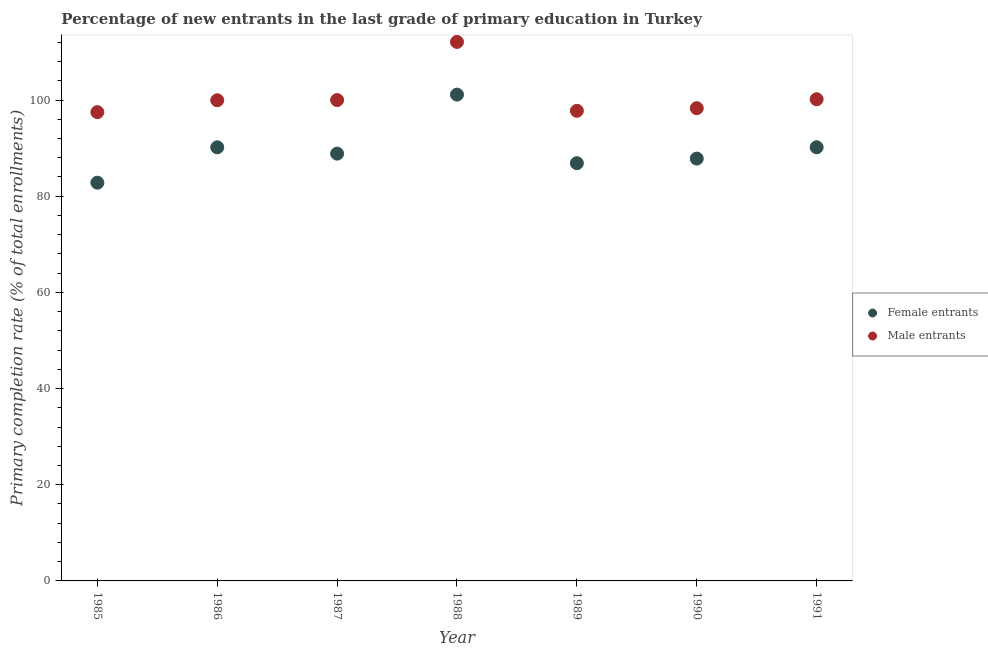How many different coloured dotlines are there?
Your response must be concise. 2. What is the primary completion rate of male entrants in 1987?
Keep it short and to the point. 99.99. Across all years, what is the maximum primary completion rate of male entrants?
Ensure brevity in your answer.  112.08. Across all years, what is the minimum primary completion rate of female entrants?
Your response must be concise. 82.81. In which year was the primary completion rate of male entrants maximum?
Provide a short and direct response. 1988. What is the total primary completion rate of female entrants in the graph?
Your answer should be very brief. 627.8. What is the difference between the primary completion rate of female entrants in 1988 and that in 1989?
Your answer should be very brief. 14.26. What is the difference between the primary completion rate of female entrants in 1985 and the primary completion rate of male entrants in 1990?
Give a very brief answer. -15.5. What is the average primary completion rate of female entrants per year?
Your answer should be very brief. 89.69. In the year 1985, what is the difference between the primary completion rate of male entrants and primary completion rate of female entrants?
Your response must be concise. 14.67. What is the ratio of the primary completion rate of male entrants in 1989 to that in 1990?
Give a very brief answer. 0.99. What is the difference between the highest and the second highest primary completion rate of male entrants?
Provide a succinct answer. 11.92. What is the difference between the highest and the lowest primary completion rate of male entrants?
Your answer should be very brief. 14.6. Is the sum of the primary completion rate of male entrants in 1985 and 1990 greater than the maximum primary completion rate of female entrants across all years?
Your response must be concise. Yes. Does the primary completion rate of female entrants monotonically increase over the years?
Offer a very short reply. No. Is the primary completion rate of male entrants strictly greater than the primary completion rate of female entrants over the years?
Your answer should be compact. Yes. Is the primary completion rate of male entrants strictly less than the primary completion rate of female entrants over the years?
Make the answer very short. No. How many dotlines are there?
Your response must be concise. 2. How many years are there in the graph?
Your answer should be very brief. 7. What is the difference between two consecutive major ticks on the Y-axis?
Your answer should be very brief. 20. Does the graph contain grids?
Provide a succinct answer. No. Where does the legend appear in the graph?
Your answer should be very brief. Center right. How many legend labels are there?
Make the answer very short. 2. How are the legend labels stacked?
Your answer should be compact. Vertical. What is the title of the graph?
Offer a very short reply. Percentage of new entrants in the last grade of primary education in Turkey. What is the label or title of the Y-axis?
Your response must be concise. Primary completion rate (% of total enrollments). What is the Primary completion rate (% of total enrollments) in Female entrants in 1985?
Your answer should be very brief. 82.81. What is the Primary completion rate (% of total enrollments) in Male entrants in 1985?
Provide a short and direct response. 97.48. What is the Primary completion rate (% of total enrollments) of Female entrants in 1986?
Provide a short and direct response. 90.16. What is the Primary completion rate (% of total enrollments) of Male entrants in 1986?
Your response must be concise. 99.95. What is the Primary completion rate (% of total enrollments) in Female entrants in 1987?
Offer a very short reply. 88.85. What is the Primary completion rate (% of total enrollments) in Male entrants in 1987?
Make the answer very short. 99.99. What is the Primary completion rate (% of total enrollments) of Female entrants in 1988?
Offer a very short reply. 101.12. What is the Primary completion rate (% of total enrollments) of Male entrants in 1988?
Your answer should be compact. 112.08. What is the Primary completion rate (% of total enrollments) in Female entrants in 1989?
Your answer should be compact. 86.86. What is the Primary completion rate (% of total enrollments) of Male entrants in 1989?
Give a very brief answer. 97.75. What is the Primary completion rate (% of total enrollments) in Female entrants in 1990?
Keep it short and to the point. 87.82. What is the Primary completion rate (% of total enrollments) of Male entrants in 1990?
Make the answer very short. 98.3. What is the Primary completion rate (% of total enrollments) in Female entrants in 1991?
Make the answer very short. 90.17. What is the Primary completion rate (% of total enrollments) in Male entrants in 1991?
Provide a short and direct response. 100.16. Across all years, what is the maximum Primary completion rate (% of total enrollments) in Female entrants?
Your response must be concise. 101.12. Across all years, what is the maximum Primary completion rate (% of total enrollments) of Male entrants?
Keep it short and to the point. 112.08. Across all years, what is the minimum Primary completion rate (% of total enrollments) in Female entrants?
Provide a succinct answer. 82.81. Across all years, what is the minimum Primary completion rate (% of total enrollments) in Male entrants?
Provide a succinct answer. 97.48. What is the total Primary completion rate (% of total enrollments) in Female entrants in the graph?
Keep it short and to the point. 627.8. What is the total Primary completion rate (% of total enrollments) of Male entrants in the graph?
Offer a very short reply. 705.71. What is the difference between the Primary completion rate (% of total enrollments) of Female entrants in 1985 and that in 1986?
Offer a very short reply. -7.35. What is the difference between the Primary completion rate (% of total enrollments) of Male entrants in 1985 and that in 1986?
Give a very brief answer. -2.47. What is the difference between the Primary completion rate (% of total enrollments) in Female entrants in 1985 and that in 1987?
Your answer should be compact. -6.05. What is the difference between the Primary completion rate (% of total enrollments) in Male entrants in 1985 and that in 1987?
Provide a short and direct response. -2.51. What is the difference between the Primary completion rate (% of total enrollments) of Female entrants in 1985 and that in 1988?
Provide a succinct answer. -18.32. What is the difference between the Primary completion rate (% of total enrollments) in Male entrants in 1985 and that in 1988?
Make the answer very short. -14.6. What is the difference between the Primary completion rate (% of total enrollments) of Female entrants in 1985 and that in 1989?
Keep it short and to the point. -4.06. What is the difference between the Primary completion rate (% of total enrollments) in Male entrants in 1985 and that in 1989?
Offer a terse response. -0.27. What is the difference between the Primary completion rate (% of total enrollments) of Female entrants in 1985 and that in 1990?
Your answer should be compact. -5.01. What is the difference between the Primary completion rate (% of total enrollments) in Male entrants in 1985 and that in 1990?
Make the answer very short. -0.82. What is the difference between the Primary completion rate (% of total enrollments) in Female entrants in 1985 and that in 1991?
Ensure brevity in your answer.  -7.37. What is the difference between the Primary completion rate (% of total enrollments) of Male entrants in 1985 and that in 1991?
Your response must be concise. -2.68. What is the difference between the Primary completion rate (% of total enrollments) of Female entrants in 1986 and that in 1987?
Give a very brief answer. 1.31. What is the difference between the Primary completion rate (% of total enrollments) in Male entrants in 1986 and that in 1987?
Provide a short and direct response. -0.04. What is the difference between the Primary completion rate (% of total enrollments) in Female entrants in 1986 and that in 1988?
Your response must be concise. -10.96. What is the difference between the Primary completion rate (% of total enrollments) in Male entrants in 1986 and that in 1988?
Your response must be concise. -12.14. What is the difference between the Primary completion rate (% of total enrollments) of Female entrants in 1986 and that in 1989?
Your answer should be very brief. 3.3. What is the difference between the Primary completion rate (% of total enrollments) in Male entrants in 1986 and that in 1989?
Provide a succinct answer. 2.19. What is the difference between the Primary completion rate (% of total enrollments) of Female entrants in 1986 and that in 1990?
Keep it short and to the point. 2.34. What is the difference between the Primary completion rate (% of total enrollments) of Male entrants in 1986 and that in 1990?
Give a very brief answer. 1.64. What is the difference between the Primary completion rate (% of total enrollments) in Female entrants in 1986 and that in 1991?
Give a very brief answer. -0.01. What is the difference between the Primary completion rate (% of total enrollments) of Male entrants in 1986 and that in 1991?
Offer a terse response. -0.21. What is the difference between the Primary completion rate (% of total enrollments) in Female entrants in 1987 and that in 1988?
Provide a short and direct response. -12.27. What is the difference between the Primary completion rate (% of total enrollments) of Male entrants in 1987 and that in 1988?
Offer a terse response. -12.1. What is the difference between the Primary completion rate (% of total enrollments) in Female entrants in 1987 and that in 1989?
Ensure brevity in your answer.  1.99. What is the difference between the Primary completion rate (% of total enrollments) in Male entrants in 1987 and that in 1989?
Your answer should be very brief. 2.23. What is the difference between the Primary completion rate (% of total enrollments) in Female entrants in 1987 and that in 1990?
Provide a succinct answer. 1.03. What is the difference between the Primary completion rate (% of total enrollments) of Male entrants in 1987 and that in 1990?
Make the answer very short. 1.68. What is the difference between the Primary completion rate (% of total enrollments) in Female entrants in 1987 and that in 1991?
Your answer should be very brief. -1.32. What is the difference between the Primary completion rate (% of total enrollments) of Male entrants in 1987 and that in 1991?
Your answer should be compact. -0.17. What is the difference between the Primary completion rate (% of total enrollments) of Female entrants in 1988 and that in 1989?
Provide a short and direct response. 14.26. What is the difference between the Primary completion rate (% of total enrollments) of Male entrants in 1988 and that in 1989?
Offer a terse response. 14.33. What is the difference between the Primary completion rate (% of total enrollments) of Female entrants in 1988 and that in 1990?
Make the answer very short. 13.3. What is the difference between the Primary completion rate (% of total enrollments) of Male entrants in 1988 and that in 1990?
Your answer should be compact. 13.78. What is the difference between the Primary completion rate (% of total enrollments) of Female entrants in 1988 and that in 1991?
Give a very brief answer. 10.95. What is the difference between the Primary completion rate (% of total enrollments) in Male entrants in 1988 and that in 1991?
Offer a terse response. 11.92. What is the difference between the Primary completion rate (% of total enrollments) of Female entrants in 1989 and that in 1990?
Keep it short and to the point. -0.96. What is the difference between the Primary completion rate (% of total enrollments) of Male entrants in 1989 and that in 1990?
Give a very brief answer. -0.55. What is the difference between the Primary completion rate (% of total enrollments) in Female entrants in 1989 and that in 1991?
Make the answer very short. -3.31. What is the difference between the Primary completion rate (% of total enrollments) in Male entrants in 1989 and that in 1991?
Your answer should be very brief. -2.41. What is the difference between the Primary completion rate (% of total enrollments) in Female entrants in 1990 and that in 1991?
Ensure brevity in your answer.  -2.35. What is the difference between the Primary completion rate (% of total enrollments) of Male entrants in 1990 and that in 1991?
Ensure brevity in your answer.  -1.86. What is the difference between the Primary completion rate (% of total enrollments) in Female entrants in 1985 and the Primary completion rate (% of total enrollments) in Male entrants in 1986?
Ensure brevity in your answer.  -17.14. What is the difference between the Primary completion rate (% of total enrollments) in Female entrants in 1985 and the Primary completion rate (% of total enrollments) in Male entrants in 1987?
Ensure brevity in your answer.  -17.18. What is the difference between the Primary completion rate (% of total enrollments) of Female entrants in 1985 and the Primary completion rate (% of total enrollments) of Male entrants in 1988?
Make the answer very short. -29.28. What is the difference between the Primary completion rate (% of total enrollments) in Female entrants in 1985 and the Primary completion rate (% of total enrollments) in Male entrants in 1989?
Make the answer very short. -14.95. What is the difference between the Primary completion rate (% of total enrollments) of Female entrants in 1985 and the Primary completion rate (% of total enrollments) of Male entrants in 1990?
Keep it short and to the point. -15.5. What is the difference between the Primary completion rate (% of total enrollments) in Female entrants in 1985 and the Primary completion rate (% of total enrollments) in Male entrants in 1991?
Your answer should be very brief. -17.35. What is the difference between the Primary completion rate (% of total enrollments) of Female entrants in 1986 and the Primary completion rate (% of total enrollments) of Male entrants in 1987?
Offer a terse response. -9.83. What is the difference between the Primary completion rate (% of total enrollments) in Female entrants in 1986 and the Primary completion rate (% of total enrollments) in Male entrants in 1988?
Ensure brevity in your answer.  -21.92. What is the difference between the Primary completion rate (% of total enrollments) in Female entrants in 1986 and the Primary completion rate (% of total enrollments) in Male entrants in 1989?
Provide a short and direct response. -7.59. What is the difference between the Primary completion rate (% of total enrollments) in Female entrants in 1986 and the Primary completion rate (% of total enrollments) in Male entrants in 1990?
Ensure brevity in your answer.  -8.14. What is the difference between the Primary completion rate (% of total enrollments) of Female entrants in 1986 and the Primary completion rate (% of total enrollments) of Male entrants in 1991?
Make the answer very short. -10. What is the difference between the Primary completion rate (% of total enrollments) in Female entrants in 1987 and the Primary completion rate (% of total enrollments) in Male entrants in 1988?
Keep it short and to the point. -23.23. What is the difference between the Primary completion rate (% of total enrollments) of Female entrants in 1987 and the Primary completion rate (% of total enrollments) of Male entrants in 1989?
Provide a succinct answer. -8.9. What is the difference between the Primary completion rate (% of total enrollments) in Female entrants in 1987 and the Primary completion rate (% of total enrollments) in Male entrants in 1990?
Provide a short and direct response. -9.45. What is the difference between the Primary completion rate (% of total enrollments) in Female entrants in 1987 and the Primary completion rate (% of total enrollments) in Male entrants in 1991?
Your answer should be very brief. -11.31. What is the difference between the Primary completion rate (% of total enrollments) in Female entrants in 1988 and the Primary completion rate (% of total enrollments) in Male entrants in 1989?
Give a very brief answer. 3.37. What is the difference between the Primary completion rate (% of total enrollments) of Female entrants in 1988 and the Primary completion rate (% of total enrollments) of Male entrants in 1990?
Make the answer very short. 2.82. What is the difference between the Primary completion rate (% of total enrollments) in Female entrants in 1988 and the Primary completion rate (% of total enrollments) in Male entrants in 1991?
Provide a succinct answer. 0.96. What is the difference between the Primary completion rate (% of total enrollments) in Female entrants in 1989 and the Primary completion rate (% of total enrollments) in Male entrants in 1990?
Your answer should be compact. -11.44. What is the difference between the Primary completion rate (% of total enrollments) in Female entrants in 1989 and the Primary completion rate (% of total enrollments) in Male entrants in 1991?
Provide a short and direct response. -13.3. What is the difference between the Primary completion rate (% of total enrollments) in Female entrants in 1990 and the Primary completion rate (% of total enrollments) in Male entrants in 1991?
Your response must be concise. -12.34. What is the average Primary completion rate (% of total enrollments) of Female entrants per year?
Provide a short and direct response. 89.69. What is the average Primary completion rate (% of total enrollments) of Male entrants per year?
Your answer should be very brief. 100.82. In the year 1985, what is the difference between the Primary completion rate (% of total enrollments) in Female entrants and Primary completion rate (% of total enrollments) in Male entrants?
Offer a terse response. -14.67. In the year 1986, what is the difference between the Primary completion rate (% of total enrollments) in Female entrants and Primary completion rate (% of total enrollments) in Male entrants?
Provide a succinct answer. -9.79. In the year 1987, what is the difference between the Primary completion rate (% of total enrollments) in Female entrants and Primary completion rate (% of total enrollments) in Male entrants?
Your answer should be very brief. -11.13. In the year 1988, what is the difference between the Primary completion rate (% of total enrollments) of Female entrants and Primary completion rate (% of total enrollments) of Male entrants?
Make the answer very short. -10.96. In the year 1989, what is the difference between the Primary completion rate (% of total enrollments) in Female entrants and Primary completion rate (% of total enrollments) in Male entrants?
Ensure brevity in your answer.  -10.89. In the year 1990, what is the difference between the Primary completion rate (% of total enrollments) in Female entrants and Primary completion rate (% of total enrollments) in Male entrants?
Your answer should be compact. -10.48. In the year 1991, what is the difference between the Primary completion rate (% of total enrollments) in Female entrants and Primary completion rate (% of total enrollments) in Male entrants?
Your response must be concise. -9.98. What is the ratio of the Primary completion rate (% of total enrollments) in Female entrants in 1985 to that in 1986?
Provide a succinct answer. 0.92. What is the ratio of the Primary completion rate (% of total enrollments) of Male entrants in 1985 to that in 1986?
Your answer should be compact. 0.98. What is the ratio of the Primary completion rate (% of total enrollments) of Female entrants in 1985 to that in 1987?
Provide a short and direct response. 0.93. What is the ratio of the Primary completion rate (% of total enrollments) of Male entrants in 1985 to that in 1987?
Ensure brevity in your answer.  0.97. What is the ratio of the Primary completion rate (% of total enrollments) of Female entrants in 1985 to that in 1988?
Make the answer very short. 0.82. What is the ratio of the Primary completion rate (% of total enrollments) of Male entrants in 1985 to that in 1988?
Make the answer very short. 0.87. What is the ratio of the Primary completion rate (% of total enrollments) of Female entrants in 1985 to that in 1989?
Your answer should be compact. 0.95. What is the ratio of the Primary completion rate (% of total enrollments) of Female entrants in 1985 to that in 1990?
Your answer should be compact. 0.94. What is the ratio of the Primary completion rate (% of total enrollments) of Female entrants in 1985 to that in 1991?
Offer a very short reply. 0.92. What is the ratio of the Primary completion rate (% of total enrollments) in Male entrants in 1985 to that in 1991?
Ensure brevity in your answer.  0.97. What is the ratio of the Primary completion rate (% of total enrollments) in Female entrants in 1986 to that in 1987?
Provide a short and direct response. 1.01. What is the ratio of the Primary completion rate (% of total enrollments) in Male entrants in 1986 to that in 1987?
Provide a succinct answer. 1. What is the ratio of the Primary completion rate (% of total enrollments) in Female entrants in 1986 to that in 1988?
Your answer should be very brief. 0.89. What is the ratio of the Primary completion rate (% of total enrollments) of Male entrants in 1986 to that in 1988?
Ensure brevity in your answer.  0.89. What is the ratio of the Primary completion rate (% of total enrollments) of Female entrants in 1986 to that in 1989?
Offer a terse response. 1.04. What is the ratio of the Primary completion rate (% of total enrollments) of Male entrants in 1986 to that in 1989?
Ensure brevity in your answer.  1.02. What is the ratio of the Primary completion rate (% of total enrollments) in Female entrants in 1986 to that in 1990?
Your answer should be compact. 1.03. What is the ratio of the Primary completion rate (% of total enrollments) in Male entrants in 1986 to that in 1990?
Your answer should be compact. 1.02. What is the ratio of the Primary completion rate (% of total enrollments) in Female entrants in 1987 to that in 1988?
Keep it short and to the point. 0.88. What is the ratio of the Primary completion rate (% of total enrollments) in Male entrants in 1987 to that in 1988?
Offer a terse response. 0.89. What is the ratio of the Primary completion rate (% of total enrollments) of Female entrants in 1987 to that in 1989?
Give a very brief answer. 1.02. What is the ratio of the Primary completion rate (% of total enrollments) in Male entrants in 1987 to that in 1989?
Offer a very short reply. 1.02. What is the ratio of the Primary completion rate (% of total enrollments) in Female entrants in 1987 to that in 1990?
Make the answer very short. 1.01. What is the ratio of the Primary completion rate (% of total enrollments) of Male entrants in 1987 to that in 1990?
Provide a short and direct response. 1.02. What is the ratio of the Primary completion rate (% of total enrollments) of Female entrants in 1987 to that in 1991?
Your answer should be very brief. 0.99. What is the ratio of the Primary completion rate (% of total enrollments) in Male entrants in 1987 to that in 1991?
Give a very brief answer. 1. What is the ratio of the Primary completion rate (% of total enrollments) of Female entrants in 1988 to that in 1989?
Your answer should be compact. 1.16. What is the ratio of the Primary completion rate (% of total enrollments) in Male entrants in 1988 to that in 1989?
Ensure brevity in your answer.  1.15. What is the ratio of the Primary completion rate (% of total enrollments) of Female entrants in 1988 to that in 1990?
Offer a very short reply. 1.15. What is the ratio of the Primary completion rate (% of total enrollments) in Male entrants in 1988 to that in 1990?
Your answer should be very brief. 1.14. What is the ratio of the Primary completion rate (% of total enrollments) in Female entrants in 1988 to that in 1991?
Give a very brief answer. 1.12. What is the ratio of the Primary completion rate (% of total enrollments) in Male entrants in 1988 to that in 1991?
Keep it short and to the point. 1.12. What is the ratio of the Primary completion rate (% of total enrollments) in Female entrants in 1989 to that in 1990?
Ensure brevity in your answer.  0.99. What is the ratio of the Primary completion rate (% of total enrollments) of Female entrants in 1989 to that in 1991?
Ensure brevity in your answer.  0.96. What is the ratio of the Primary completion rate (% of total enrollments) of Male entrants in 1989 to that in 1991?
Your answer should be very brief. 0.98. What is the ratio of the Primary completion rate (% of total enrollments) in Female entrants in 1990 to that in 1991?
Offer a terse response. 0.97. What is the ratio of the Primary completion rate (% of total enrollments) in Male entrants in 1990 to that in 1991?
Keep it short and to the point. 0.98. What is the difference between the highest and the second highest Primary completion rate (% of total enrollments) in Female entrants?
Give a very brief answer. 10.95. What is the difference between the highest and the second highest Primary completion rate (% of total enrollments) in Male entrants?
Your answer should be compact. 11.92. What is the difference between the highest and the lowest Primary completion rate (% of total enrollments) in Female entrants?
Ensure brevity in your answer.  18.32. What is the difference between the highest and the lowest Primary completion rate (% of total enrollments) of Male entrants?
Make the answer very short. 14.6. 